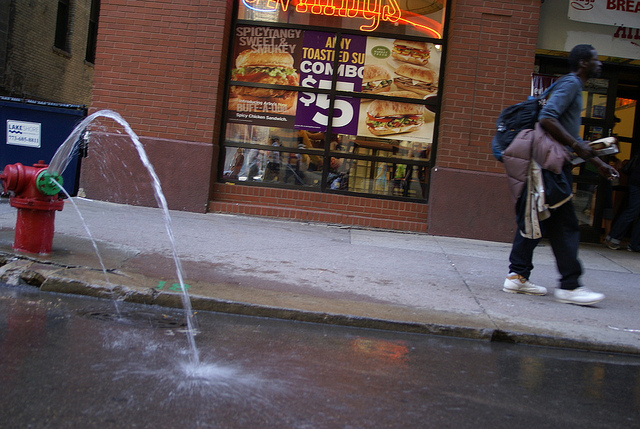<image>What Mexican restaurant is present? I am not sure which Mexican restaurant is present. It could be "Arby's", "Taco Bell", or none. What Mexican restaurant is present? There is no Mexican restaurant present in the image. 